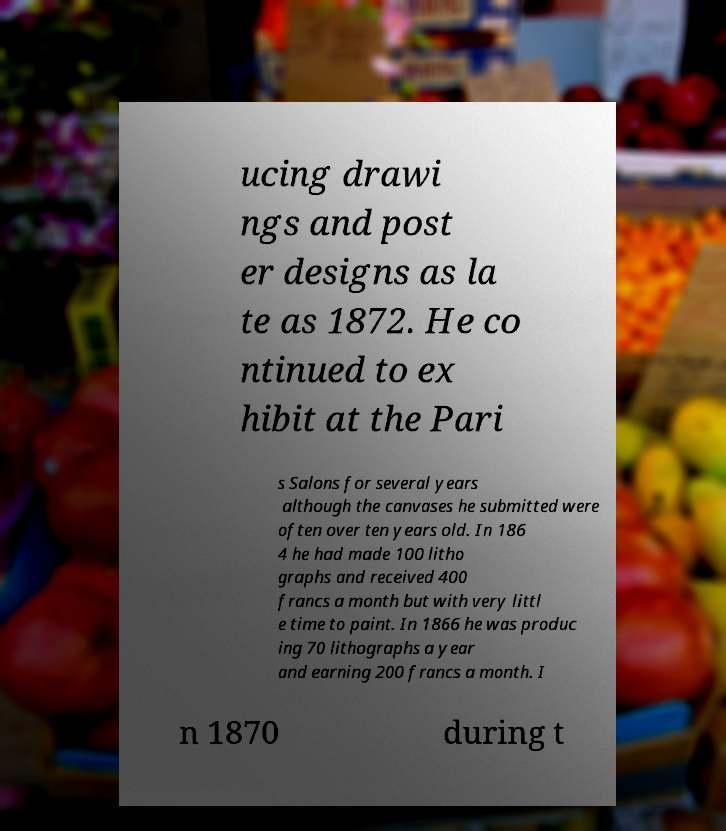I need the written content from this picture converted into text. Can you do that? ucing drawi ngs and post er designs as la te as 1872. He co ntinued to ex hibit at the Pari s Salons for several years although the canvases he submitted were often over ten years old. In 186 4 he had made 100 litho graphs and received 400 francs a month but with very littl e time to paint. In 1866 he was produc ing 70 lithographs a year and earning 200 francs a month. I n 1870 during t 